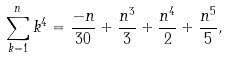Convert formula to latex. <formula><loc_0><loc_0><loc_500><loc_500>\sum _ { k = 1 } ^ { n } k ^ { 4 } = \frac { - n } { 3 0 } + \frac { n ^ { 3 } } { 3 } + \frac { n ^ { 4 } } { 2 } + \frac { n ^ { 5 } } { 5 } ,</formula> 